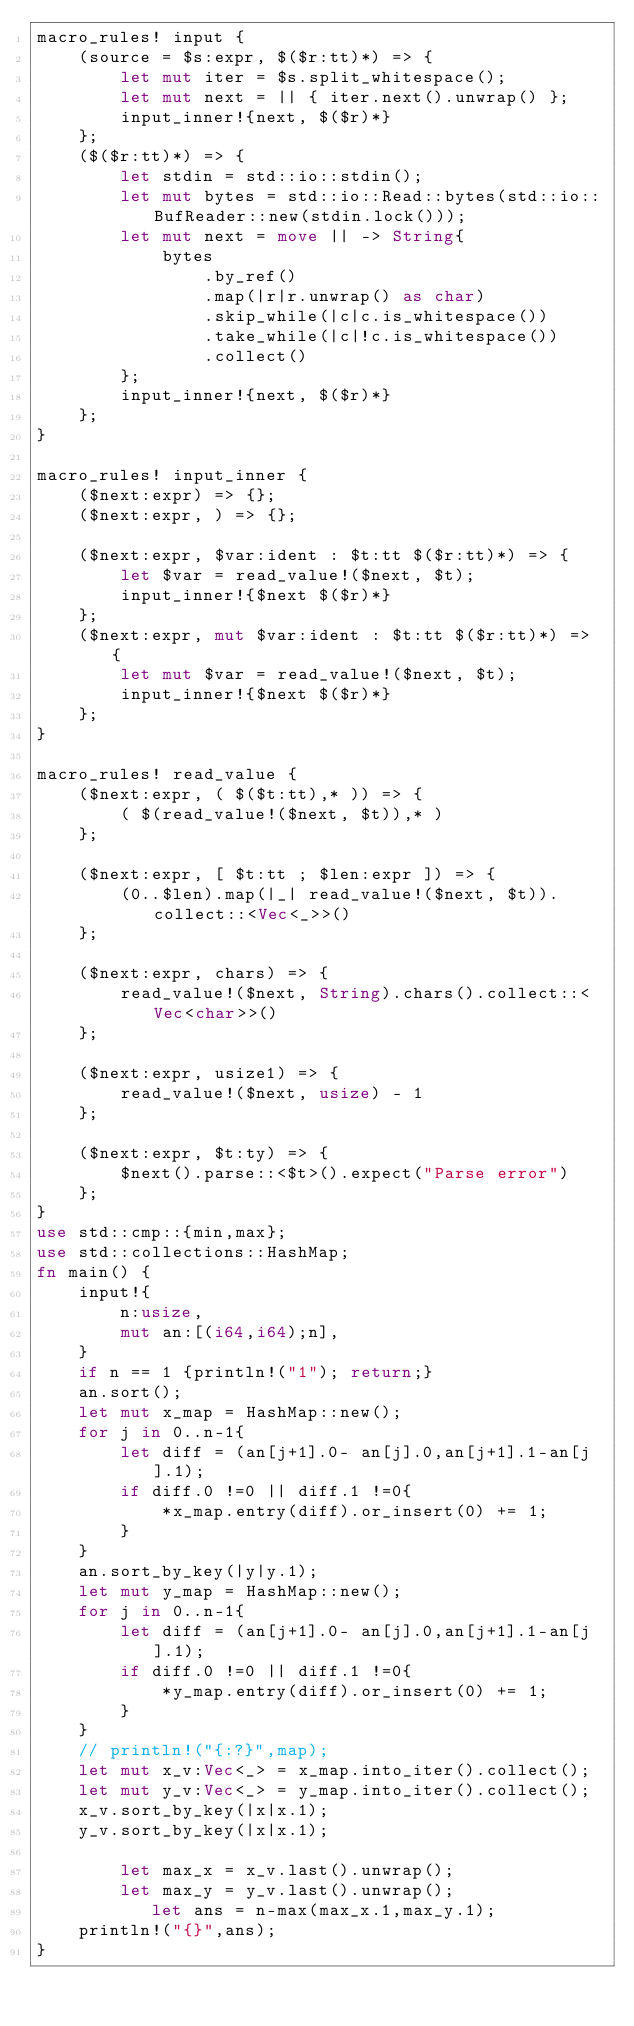Convert code to text. <code><loc_0><loc_0><loc_500><loc_500><_Rust_>macro_rules! input {
    (source = $s:expr, $($r:tt)*) => {
        let mut iter = $s.split_whitespace();
        let mut next = || { iter.next().unwrap() };
        input_inner!{next, $($r)*}
    };
    ($($r:tt)*) => {
        let stdin = std::io::stdin();
        let mut bytes = std::io::Read::bytes(std::io::BufReader::new(stdin.lock()));
        let mut next = move || -> String{
            bytes
                .by_ref()
                .map(|r|r.unwrap() as char)
                .skip_while(|c|c.is_whitespace())
                .take_while(|c|!c.is_whitespace())
                .collect()
        };
        input_inner!{next, $($r)*}
    };
}

macro_rules! input_inner {
    ($next:expr) => {};
    ($next:expr, ) => {};

    ($next:expr, $var:ident : $t:tt $($r:tt)*) => {
        let $var = read_value!($next, $t);
        input_inner!{$next $($r)*}
    };
    ($next:expr, mut $var:ident : $t:tt $($r:tt)*) => {
        let mut $var = read_value!($next, $t);
        input_inner!{$next $($r)*}
    };
}

macro_rules! read_value {
    ($next:expr, ( $($t:tt),* )) => {
        ( $(read_value!($next, $t)),* )
    };

    ($next:expr, [ $t:tt ; $len:expr ]) => {
        (0..$len).map(|_| read_value!($next, $t)).collect::<Vec<_>>()
    };

    ($next:expr, chars) => {
        read_value!($next, String).chars().collect::<Vec<char>>()
    };

    ($next:expr, usize1) => {
        read_value!($next, usize) - 1
    };

    ($next:expr, $t:ty) => {
        $next().parse::<$t>().expect("Parse error")
    };
}
use std::cmp::{min,max};
use std::collections::HashMap;
fn main() {
    input!{
        n:usize,
        mut an:[(i64,i64);n],
    }
    if n == 1 {println!("1"); return;}
    an.sort();
    let mut x_map = HashMap::new();
    for j in 0..n-1{
        let diff = (an[j+1].0- an[j].0,an[j+1].1-an[j].1);
        if diff.0 !=0 || diff.1 !=0{
            *x_map.entry(diff).or_insert(0) += 1;
        }
    }
    an.sort_by_key(|y|y.1);
    let mut y_map = HashMap::new();
    for j in 0..n-1{
        let diff = (an[j+1].0- an[j].0,an[j+1].1-an[j].1);
        if diff.0 !=0 || diff.1 !=0{
            *y_map.entry(diff).or_insert(0) += 1;
        }
    }
    // println!("{:?}",map);
    let mut x_v:Vec<_> = x_map.into_iter().collect();
    let mut y_v:Vec<_> = y_map.into_iter().collect();
    x_v.sort_by_key(|x|x.1);
    y_v.sort_by_key(|x|x.1);

        let max_x = x_v.last().unwrap();
        let max_y = y_v.last().unwrap();
           let ans = n-max(max_x.1,max_y.1);
    println!("{}",ans);
}</code> 